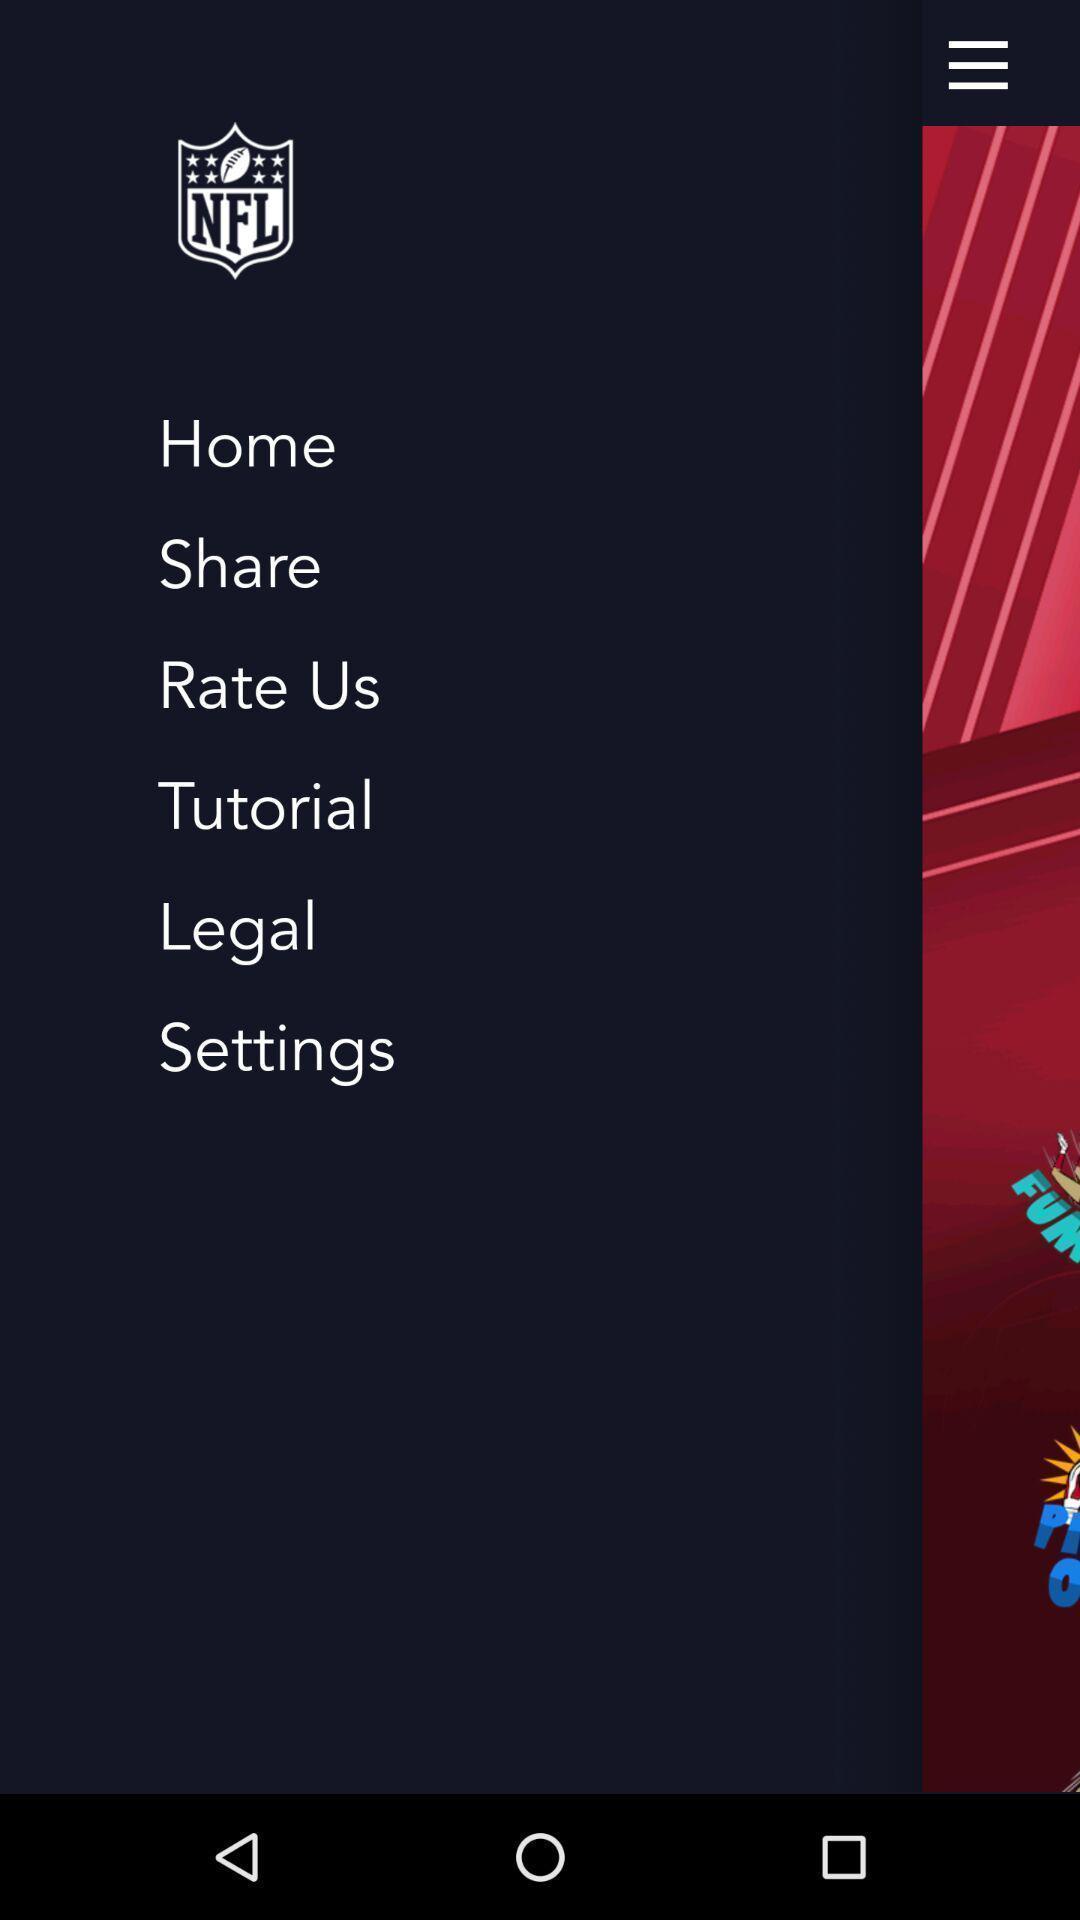Describe the key features of this screenshot. Page showing different options like home. 